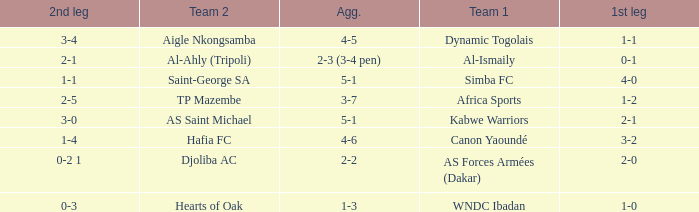What was the 2nd leg result in the match that scored a 2-0 in the 1st leg? 0-2 1. 